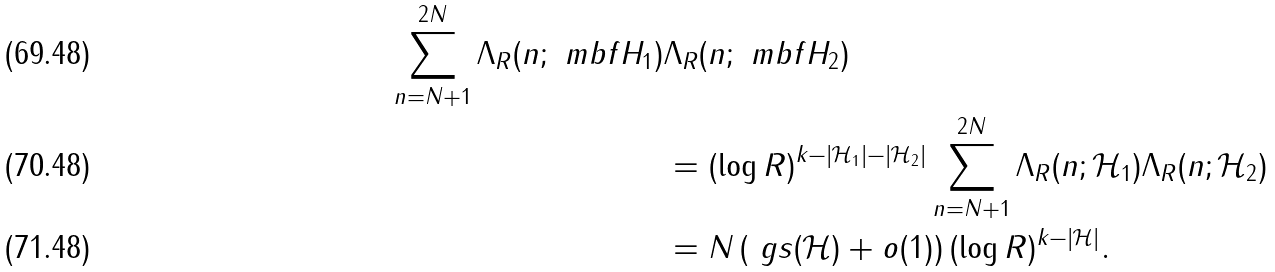<formula> <loc_0><loc_0><loc_500><loc_500>\sum _ { n = N + 1 } ^ { 2 N } \Lambda _ { R } ( n ; \ m b f { H } _ { 1 } ) & \Lambda _ { R } ( n ; \ m b f { H } _ { 2 } ) \\ & = ( \log R ) ^ { k - | \mathcal { H } _ { 1 } | - | \mathcal { H } _ { 2 } | } \sum _ { n = N + 1 } ^ { 2 N } \Lambda _ { R } ( n ; \mathcal { H } _ { 1 } ) \Lambda _ { R } ( n ; \mathcal { H } _ { 2 } ) \\ & = N \left ( \ g s ( \mathcal { H } ) + o ( 1 ) \right ) ( \log R ) ^ { k - | \mathcal { H } | } .</formula> 